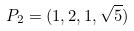<formula> <loc_0><loc_0><loc_500><loc_500>P _ { 2 } = ( 1 , 2 , 1 , \sqrt { 5 } )</formula> 